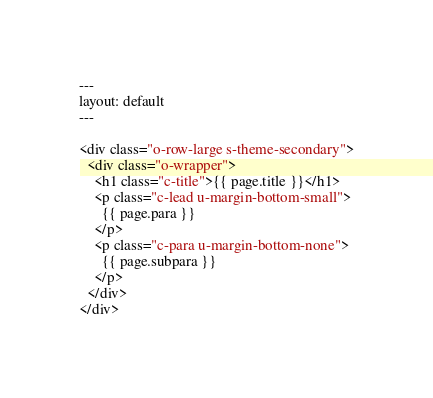<code> <loc_0><loc_0><loc_500><loc_500><_HTML_>---
layout: default
---

<div class="o-row-large s-theme-secondary">
  <div class="o-wrapper">
    <h1 class="c-title">{{ page.title }}</h1>
    <p class="c-lead u-margin-bottom-small">
      {{ page.para }}
    </p>
    <p class="c-para u-margin-bottom-none">
      {{ page.subpara }}
    </p>
  </div>
</div>
</code> 